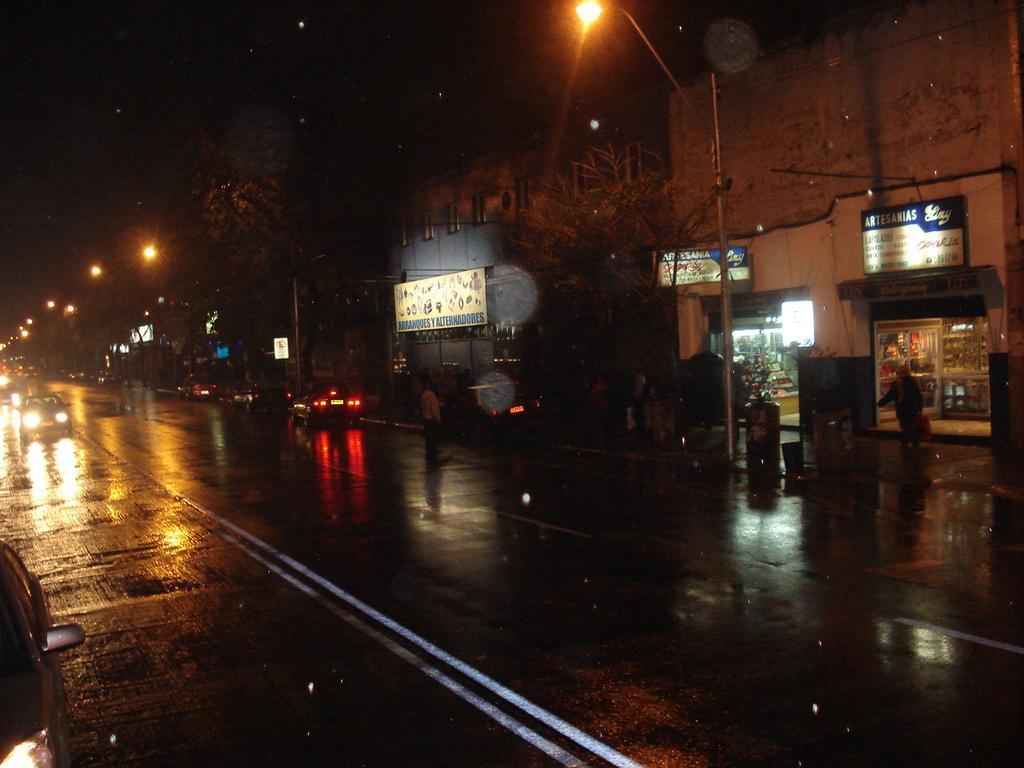How would you summarize this image in a sentence or two? In this picture, we can see some vehicles are moving on the road and on the right side of the vehicles there is a path and on the path there are poles with lights, trees, hoardings, buildings. 